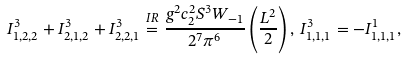<formula> <loc_0><loc_0><loc_500><loc_500>I ^ { 3 } _ { 1 , 2 , 2 } + I ^ { 3 } _ { 2 , 1 , 2 } + I ^ { 3 } _ { 2 , 2 , 1 } \stackrel { I R } { = } \frac { g ^ { 2 } c ^ { 2 } _ { 2 } S ^ { 3 } W _ { - 1 } } { 2 ^ { 7 } \pi ^ { 6 } } \left ( \frac { L ^ { 2 } } { 2 } \right ) , \, I ^ { 3 } _ { 1 , 1 , 1 } = - I ^ { 1 } _ { 1 , 1 , 1 } ,</formula> 